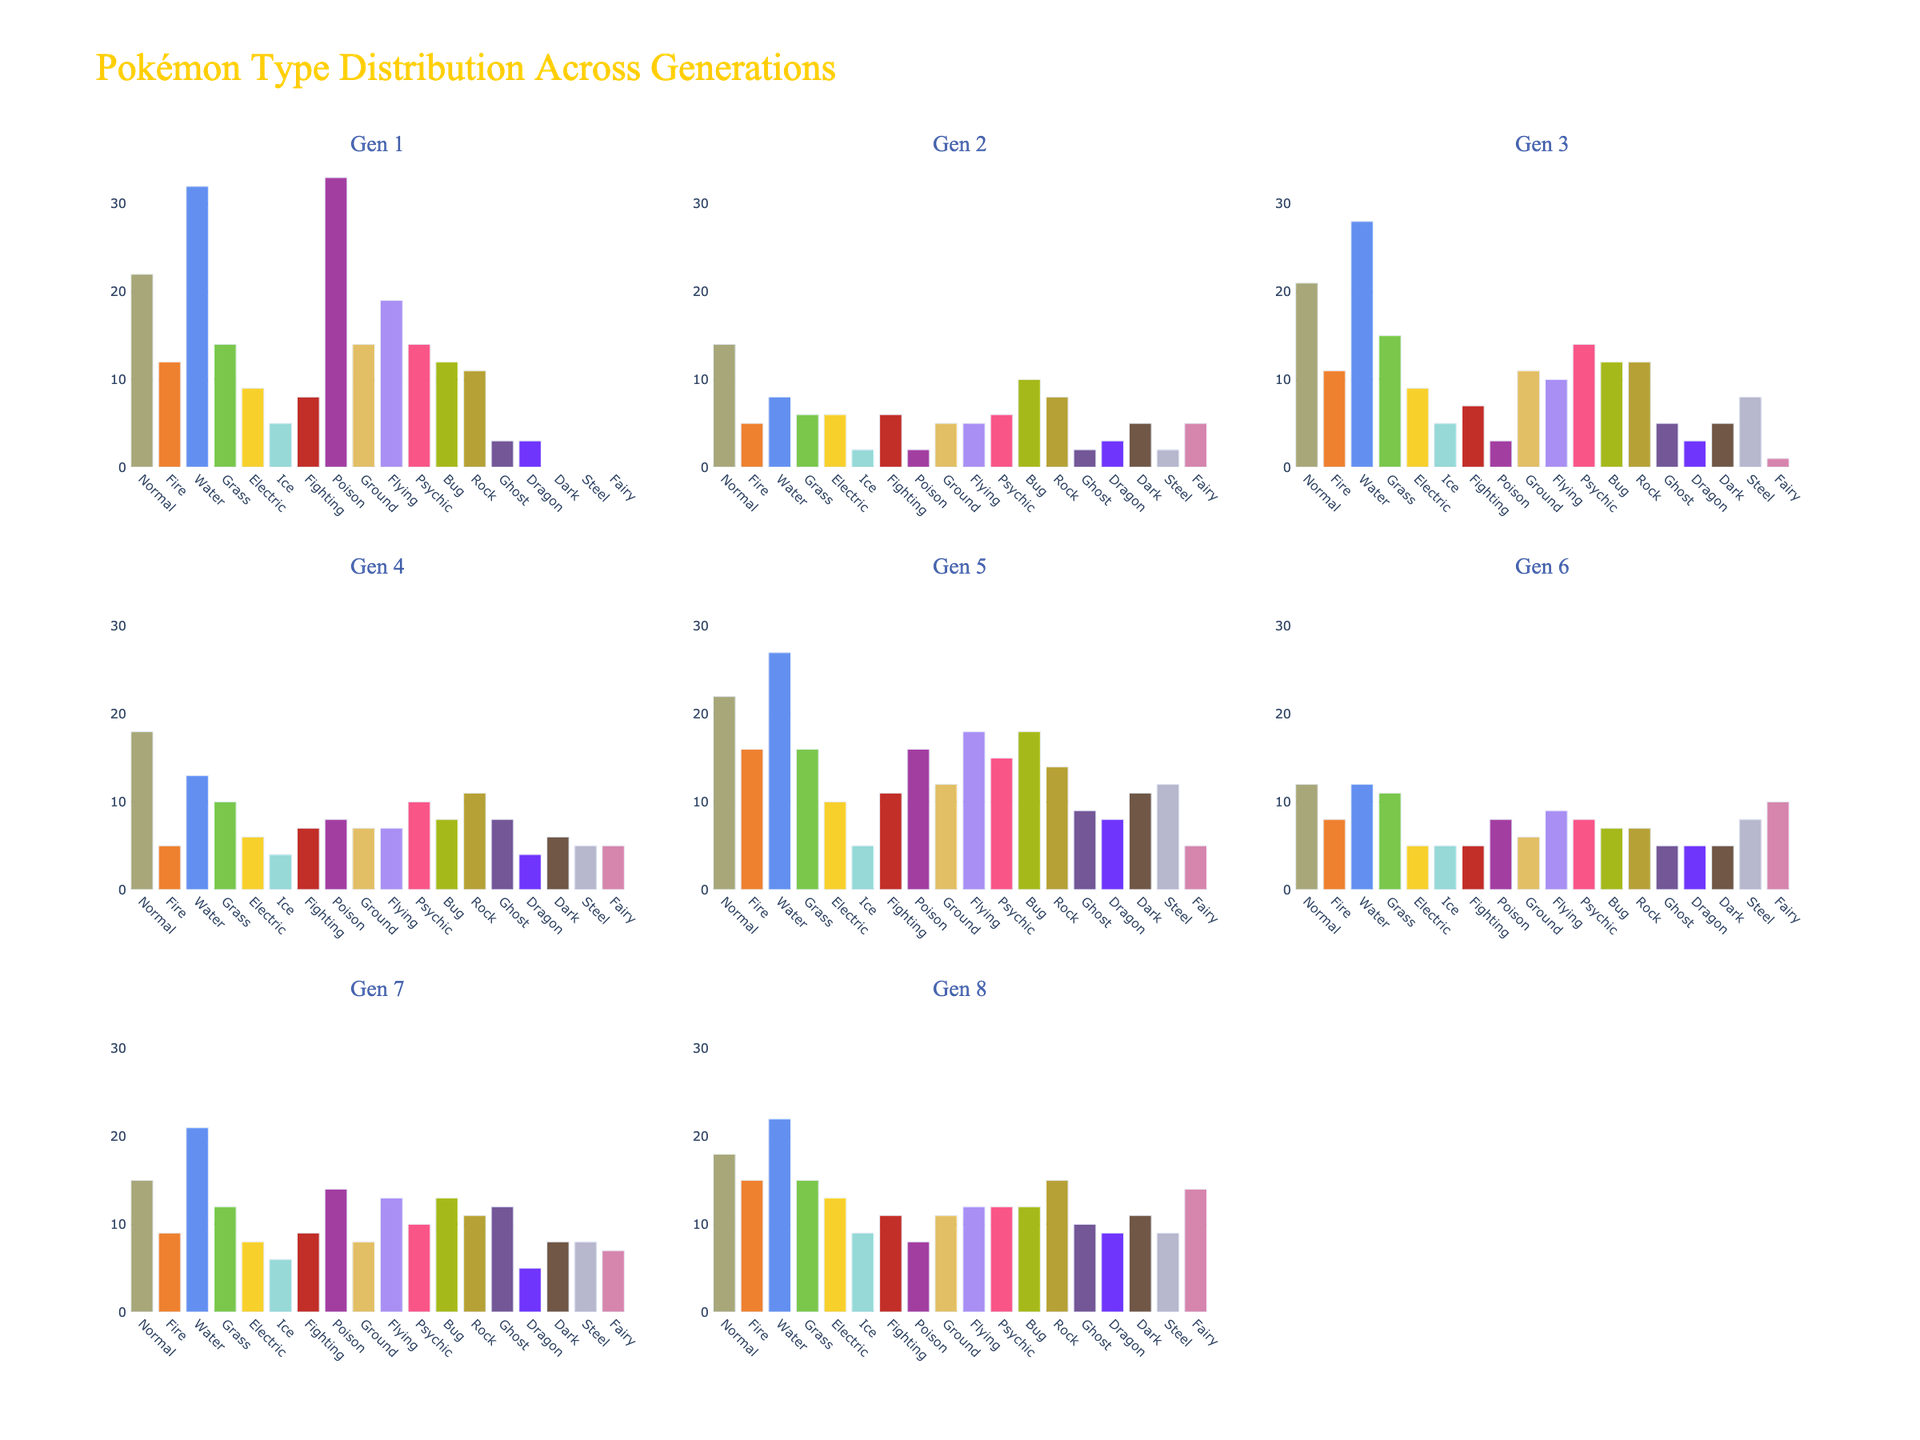What is the title of the figure? The title is displayed at the top of the figure. It summarizes the overall content of the plot.
Answer: Pokémon Type Distribution Across Generations Which generation has the highest number of Water-type Pokémon? By comparing the Water-type bars across all subplots, the longest bar represents the generation with the most Water-type Pokémon. Generation 1 has the highest number with 32 Water-type Pokémon.
Answer: Generation 1 How many Fairy-type Pokémon are there in Generations 6 and 8 combined? Add the number of Fairy-type Pokémon in Generation 6 (10) and Generation 8 (14). The sum is 24.
Answer: 24 Which type has the lowest count in Generation 4? By looking at the subplot for Generation 4 and identifying the shortest bar, we find that Fire-type Pokémon has the lowest count with 5.
Answer: Fire How does the number of Psychic-type Pokémon in Generation 5 compare to Generation 7? Compare the heights of the bars representing Psychic-type Pokémon in Generation 5 (15) and Generation 7 (10). Generation 5 has more Psychic-type Pokémon.
Answer: Generation 5 has more Is there any type that has zero Pokémon in Generation 1? By checking the bars in Generation 1’s subplot, we see that Dark, Steel, and Fairy types have zero Pokémon.
Answer: Dark, Steel, Fairy Which generation has the most even distribution of Pokémon types? The most even distribution means the bars have relatively similar heights. Generation 7's bars are more evenly distributed compared to others.
Answer: Generation 7 How many total Pokémon are there in Generation 2? By adding the counts of all types in Generation 2: 14 + 5 + 8 + 6 + 6 + 2 + 6 + 2 + 5 + 5 + 6 + 10 + 8 + 2 + 3 + 5 + 2 + 5 = 100.
Answer: 100 Which type sees the most significant increase from Generation 6 to Generation 8? Comparing each type's bars between Generations 6 and 8, Fairy-type Pokémon increase from 10 to 14. This is a 4-Pokémon increase, which is the largest.
Answer: Fairy Which type is more common in Generation 3 compared to Generation 2? Look at the subplots for Generations 2 and 3 and compare the types. Water-type Pokémon are significantly more common in Generation 3 (28) compared to Generation 2 (8).
Answer: Water 